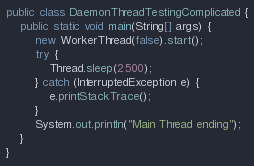<code> <loc_0><loc_0><loc_500><loc_500><_Java_>
public class DaemonThreadTestingComplicated {
    public static void main(String[] args) {
        new WorkerThread(false).start();
        try {
            Thread.sleep(2500);
        } catch (InterruptedException e) {
            e.printStackTrace();
        }
        System.out.println("Main Thread ending");
    }
}
</code> 